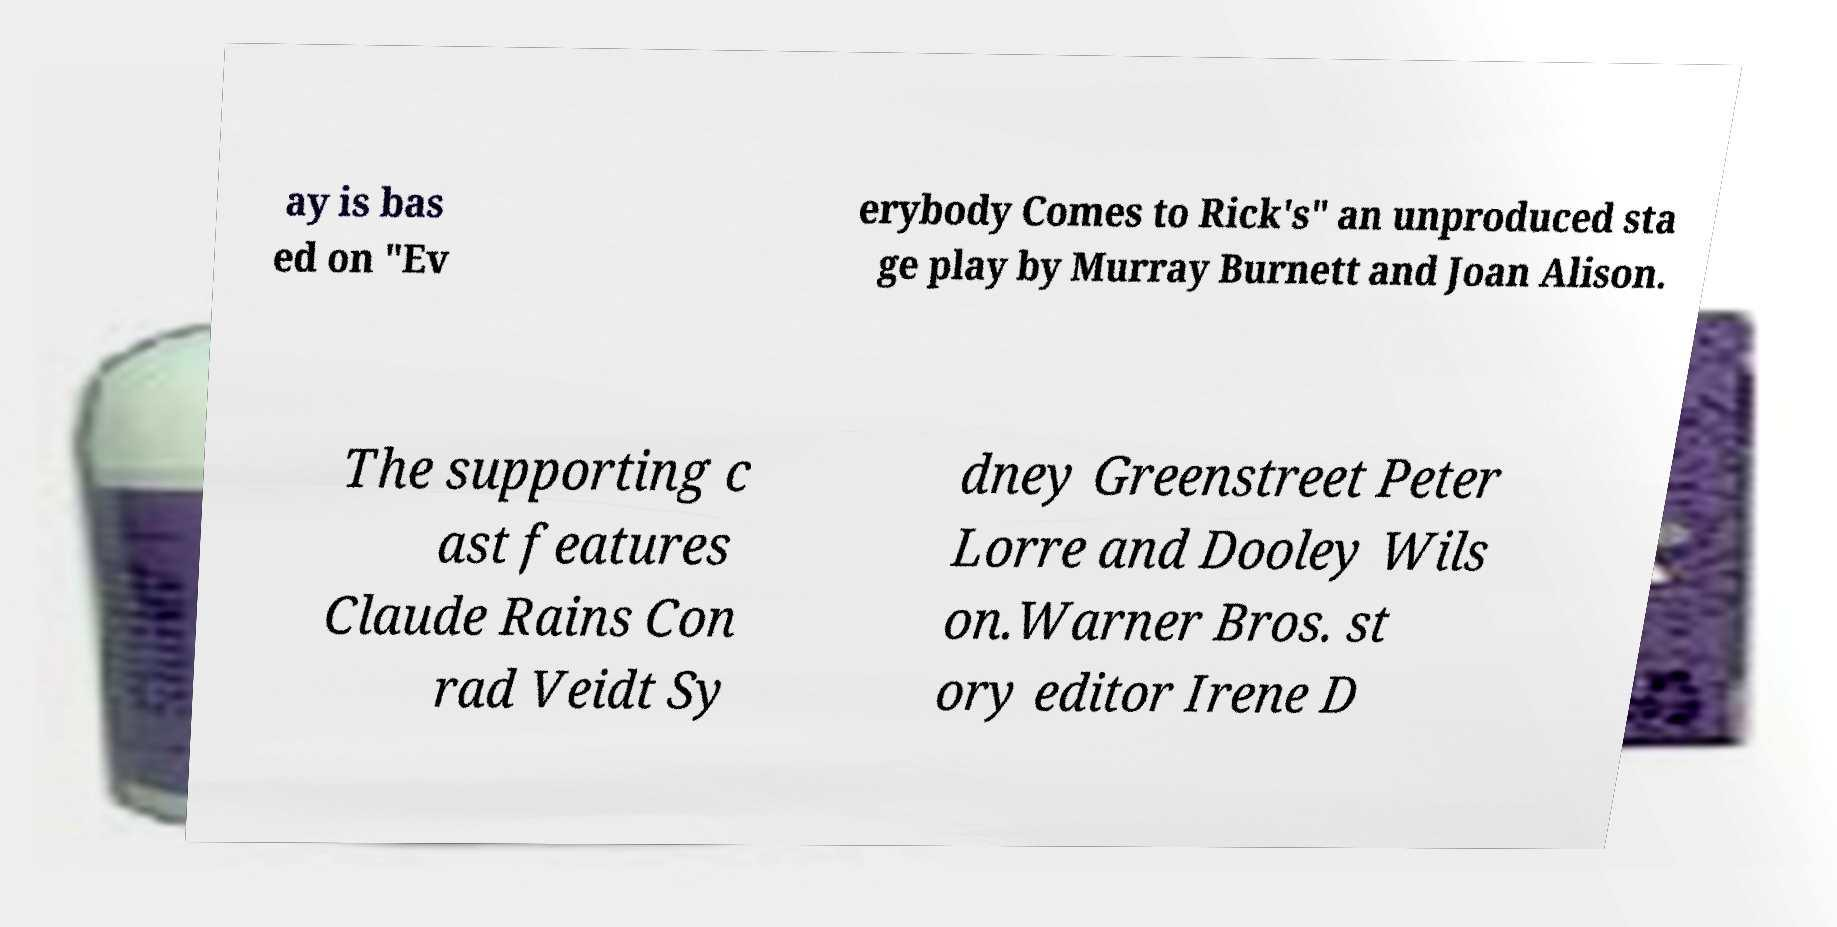What messages or text are displayed in this image? I need them in a readable, typed format. ay is bas ed on "Ev erybody Comes to Rick's" an unproduced sta ge play by Murray Burnett and Joan Alison. The supporting c ast features Claude Rains Con rad Veidt Sy dney Greenstreet Peter Lorre and Dooley Wils on.Warner Bros. st ory editor Irene D 